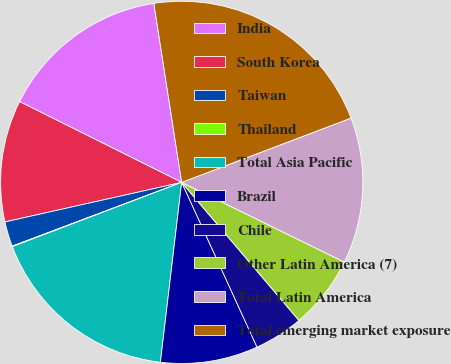Convert chart. <chart><loc_0><loc_0><loc_500><loc_500><pie_chart><fcel>India<fcel>South Korea<fcel>Taiwan<fcel>Thailand<fcel>Total Asia Pacific<fcel>Brazil<fcel>Chile<fcel>Other Latin America (7)<fcel>Total Latin America<fcel>Total emerging market exposure<nl><fcel>15.19%<fcel>10.86%<fcel>2.22%<fcel>0.05%<fcel>17.35%<fcel>8.7%<fcel>4.38%<fcel>6.54%<fcel>13.03%<fcel>21.68%<nl></chart> 